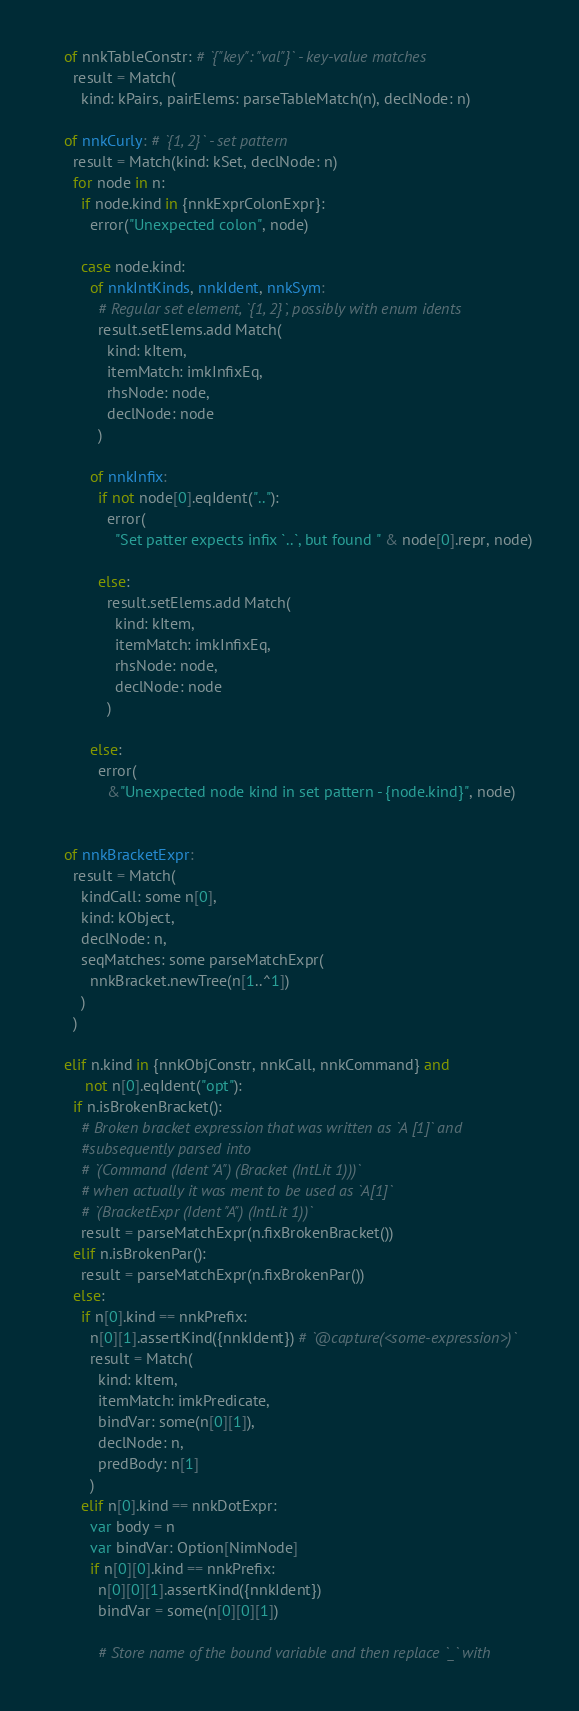Convert code to text. <code><loc_0><loc_0><loc_500><loc_500><_Nim_>    of nnkTableConstr: # `{"key": "val"}` - key-value matches
      result = Match(
        kind: kPairs, pairElems: parseTableMatch(n), declNode: n)

    of nnkCurly: # `{1, 2}` - set pattern
      result = Match(kind: kSet, declNode: n)
      for node in n:
        if node.kind in {nnkExprColonExpr}:
          error("Unexpected colon", node)

        case node.kind:
          of nnkIntKinds, nnkIdent, nnkSym:
            # Regular set element, `{1, 2}`, possibly with enum idents
            result.setElems.add Match(
              kind: kItem,
              itemMatch: imkInfixEq,
              rhsNode: node,
              declNode: node
            )

          of nnkInfix:
            if not node[0].eqIdent(".."):
              error(
                "Set patter expects infix `..`, but found " & node[0].repr, node)

            else:
              result.setElems.add Match(
                kind: kItem,
                itemMatch: imkInfixEq,
                rhsNode: node,
                declNode: node
              )

          else:
            error(
              &"Unexpected node kind in set pattern - {node.kind}", node)


    of nnkBracketExpr:
      result = Match(
        kindCall: some n[0],
        kind: kObject,
        declNode: n,
        seqMatches: some parseMatchExpr(
          nnkBracket.newTree(n[1..^1])
        )
      )

    elif n.kind in {nnkObjConstr, nnkCall, nnkCommand} and
         not n[0].eqIdent("opt"):
      if n.isBrokenBracket():
        # Broken bracket expression that was written as `A [1]` and
        #subsequently parsed into
        # `(Command (Ident "A") (Bracket (IntLit 1)))`
        # when actually it was ment to be used as `A[1]`
        # `(BracketExpr (Ident "A") (IntLit 1))`
        result = parseMatchExpr(n.fixBrokenBracket())
      elif n.isBrokenPar():
        result = parseMatchExpr(n.fixBrokenPar())
      else:
        if n[0].kind == nnkPrefix:
          n[0][1].assertKind({nnkIdent}) # `@capture(<some-expression>)`
          result = Match(
            kind: kItem,
            itemMatch: imkPredicate,
            bindVar: some(n[0][1]),
            declNode: n,
            predBody: n[1]
          )
        elif n[0].kind == nnkDotExpr:
          var body = n
          var bindVar: Option[NimNode]
          if n[0][0].kind == nnkPrefix:
            n[0][0][1].assertKind({nnkIdent})
            bindVar = some(n[0][0][1])

            # Store name of the bound variable and then replace `_` with</code> 